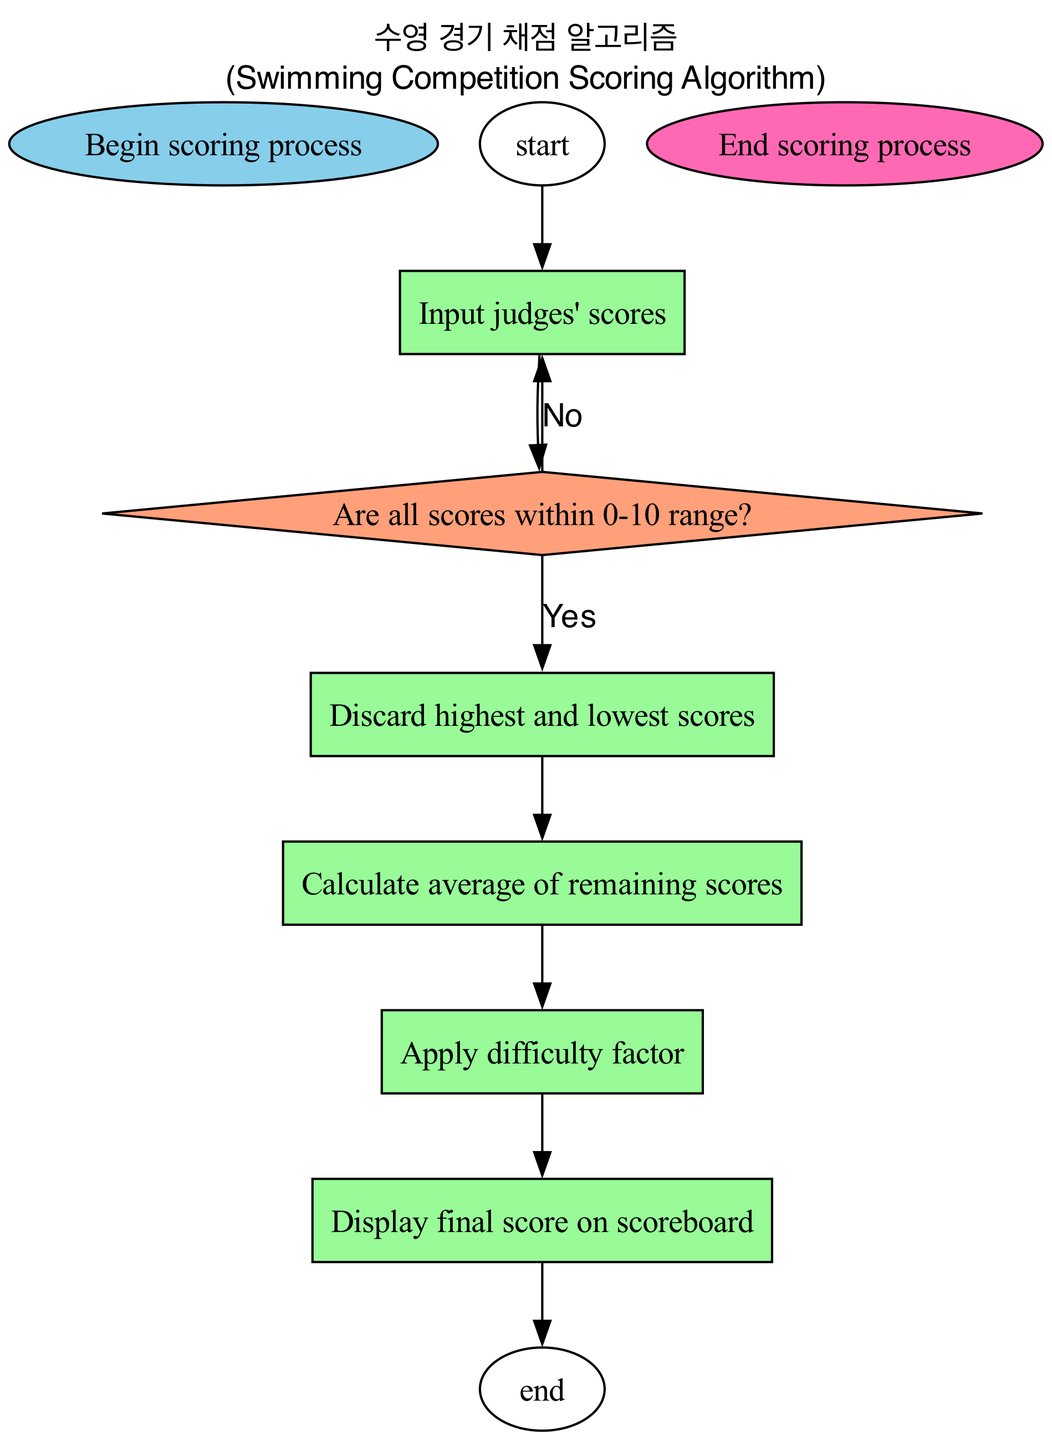What is the first step in the flowchart? The first step in the flowchart is indicated by the 'start' node, which states, "Begin scoring process." This is the initial action that sets off the entire scoring sequence.
Answer: Begin scoring process How many decision nodes are in the flowchart? By reviewing the flowchart's nodes, there is one decision node present, which asks, "Are all scores within 0-10 range?" This identifies whether the judges' scores are valid for further processing.
Answer: One What happens if the scores are not within the 0-10 range? If the scores are not within the specified range, the flow arrow points back to the 'Input judges' scores' node. This indicates that the process will return to collecting the scores from the judges for correction.
Answer: Input judges' scores What is the final action taken in the scoring process? The final action taken in the flowchart is indicated by the 'end' node, which states, "End scoring process." This signifies the conclusion of the scoring operations after displaying the final score.
Answer: End scoring process Which step immediately follows the calculation of the average of remaining scores? After calculating the average of the remaining scores, the next step indicated in the flowchart is "Apply difficulty factor." This step adjusts the score based on the difficulty level of the performance.
Answer: Apply difficulty factor What type of node is used to indicate the scoring decision step? The scoring decision step, asking "Are all scores within 0-10 range?", is represented by a decision node, characterized by its diamond shape in the diagram. This node type is used for questions requiring a 'yes' or 'no' response.
Answer: Decision node Where do the scores get displayed after processing? The scores are displayed in the "Display final score on scoreboard" process, which indicates where the calculated score is shown following all previous calculations and adjustments.
Answer: Display final score on scoreboard What process occurs after discarding the highest and lowest scores? Following the action of discarding the highest and lowest scores, the next process in the flowchart is to "Calculate average of remaining scores." This computation is essential for deriving the final score for the performance.
Answer: Calculate average of remaining scores 